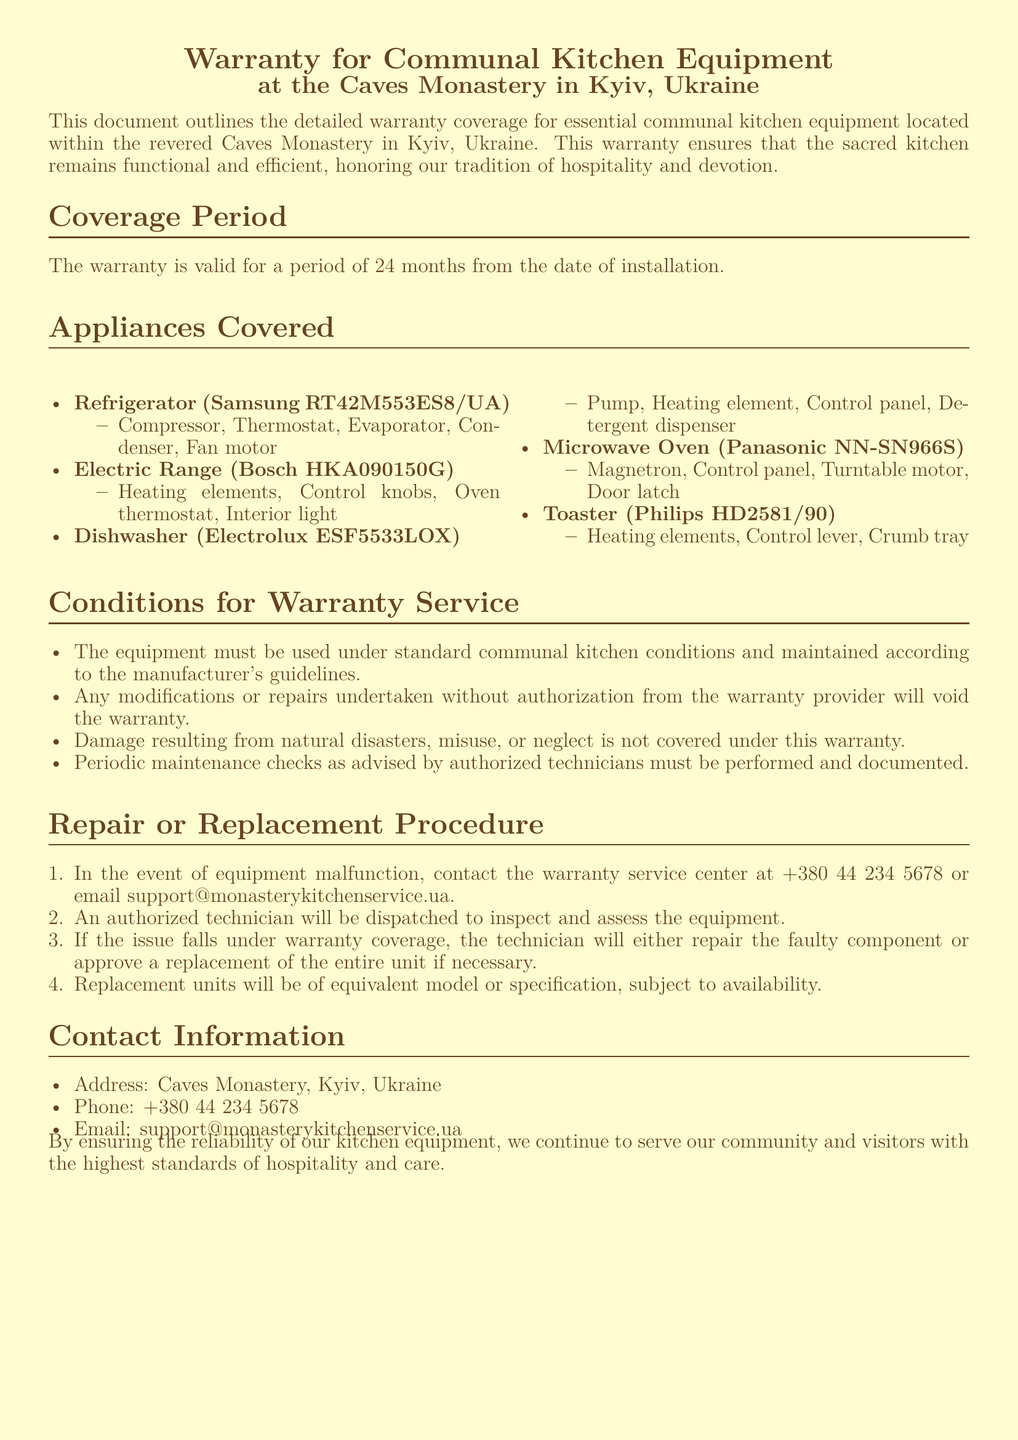What is the coverage period of the warranty? The warranty is valid for a period of 24 months from the date of installation.
Answer: 24 months Which refrigerator model is covered by the warranty? The document lists the specific refrigerator model covered by the warranty.
Answer: Samsung RT42M553ES8/UA What types of damage are not covered under the warranty? The conditions for warranty service note specific reasons that would void coverage.
Answer: Natural disasters, misuse, neglect What is the first step in the repair or replacement procedure? The document outlines the procedure and the first action to take when malfunction occurs.
Answer: Contact the warranty service center What information should be documented according to the warranty? The conditions for warranty service specify a requirement for maintenance documentation.
Answer: Periodic maintenance checks 